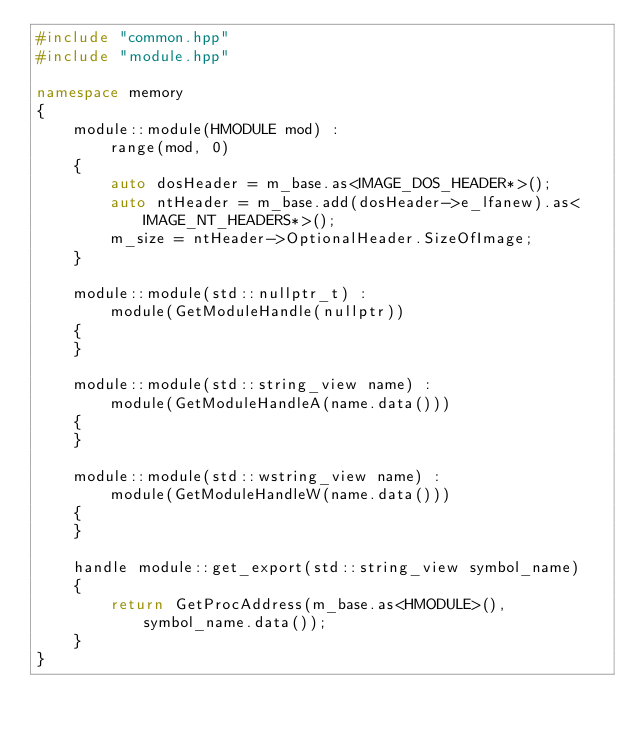<code> <loc_0><loc_0><loc_500><loc_500><_C++_>#include "common.hpp"
#include "module.hpp"

namespace memory
{
	module::module(HMODULE mod) :
		range(mod, 0)
	{
		auto dosHeader = m_base.as<IMAGE_DOS_HEADER*>();
		auto ntHeader = m_base.add(dosHeader->e_lfanew).as<IMAGE_NT_HEADERS*>();
		m_size = ntHeader->OptionalHeader.SizeOfImage;
	}

	module::module(std::nullptr_t) :
		module(GetModuleHandle(nullptr))
	{
	}

	module::module(std::string_view name) :
		module(GetModuleHandleA(name.data()))
	{
	}

	module::module(std::wstring_view name) :
		module(GetModuleHandleW(name.data()))
	{
	}

	handle module::get_export(std::string_view symbol_name)
	{
		return GetProcAddress(m_base.as<HMODULE>(), symbol_name.data());
	}
}
</code> 